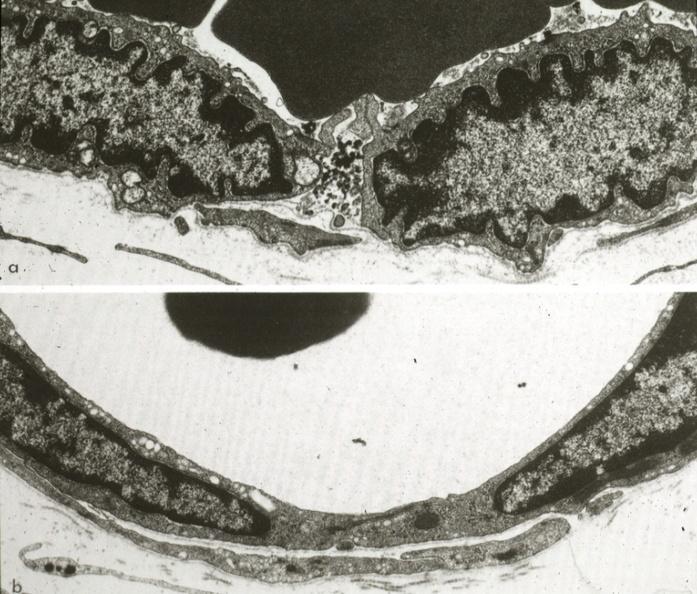does this image show continuous type illustrating opened and closed intercellular junction?
Answer the question using a single word or phrase. Yes 